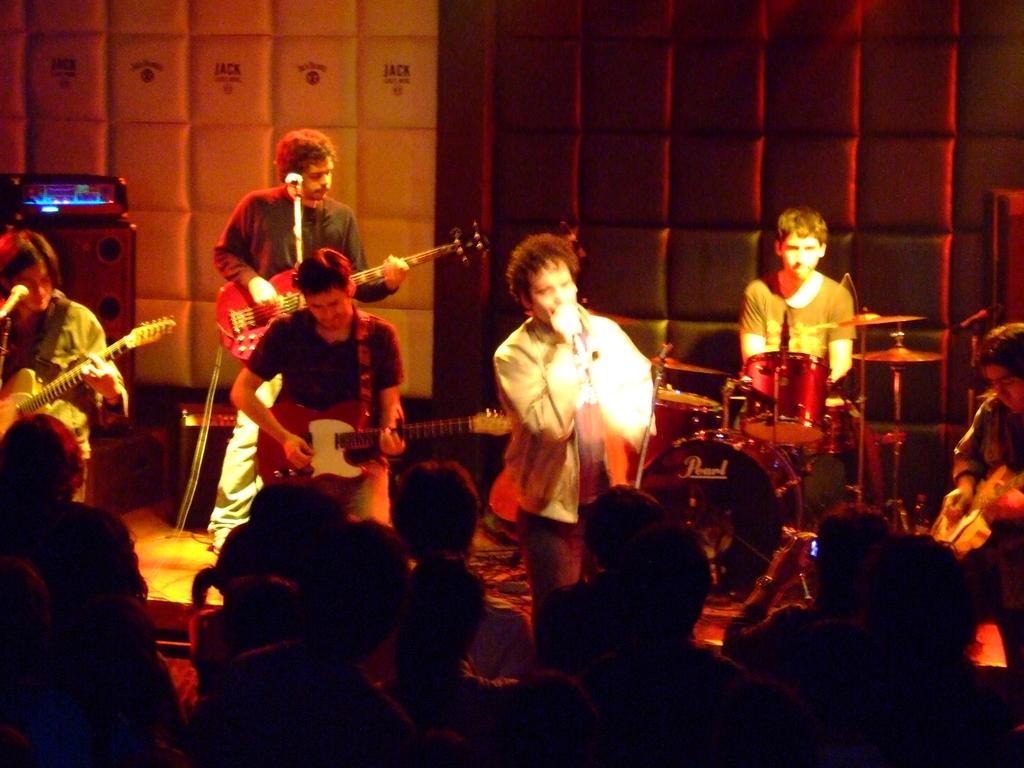Can you describe this image briefly? In this image there are 3 persons standing and playing a guitar , another person standing and singing a song in the microphone, another man sitting and playing drums, another person standing and playing a guitar and at the back ground there is CD player, speaker, wall, light , group of people. 